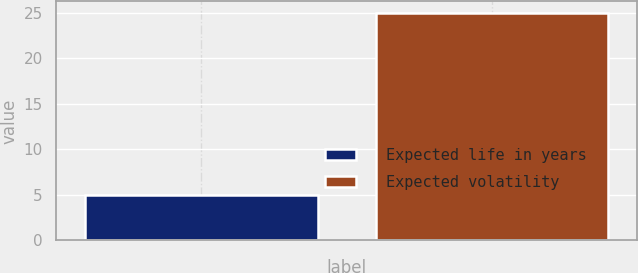<chart> <loc_0><loc_0><loc_500><loc_500><bar_chart><fcel>Expected life in years<fcel>Expected volatility<nl><fcel>5<fcel>25<nl></chart> 